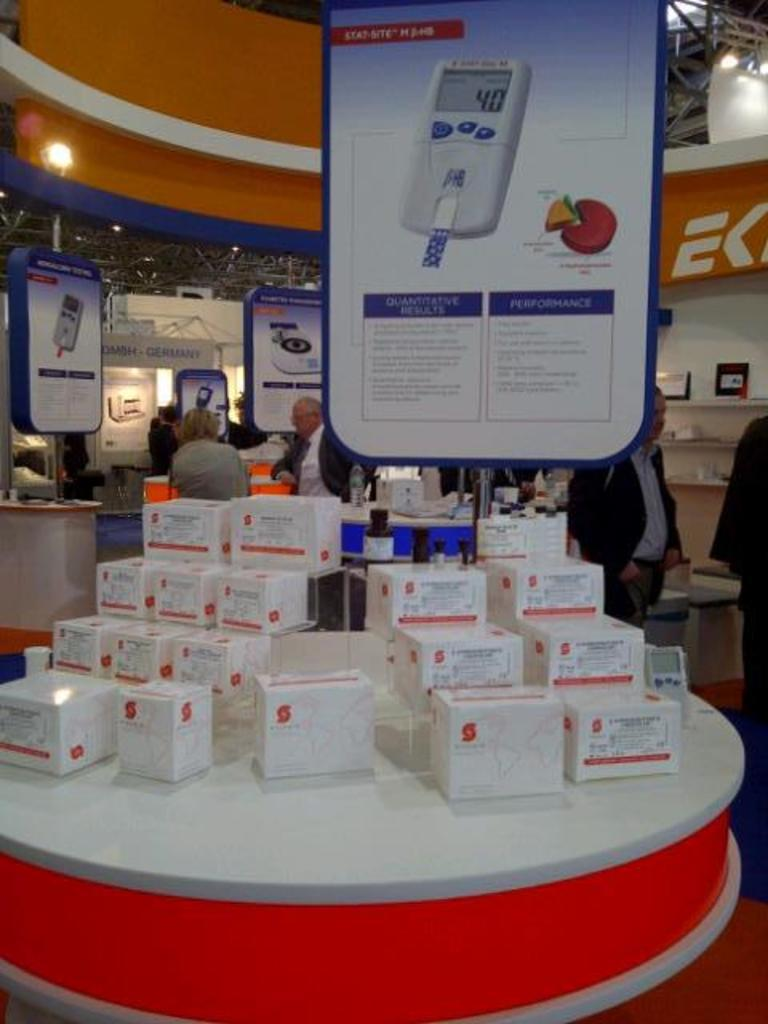Provide a one-sentence caption for the provided image. A store with lots of boxes for sale and an ad that talks about the devices performance. 